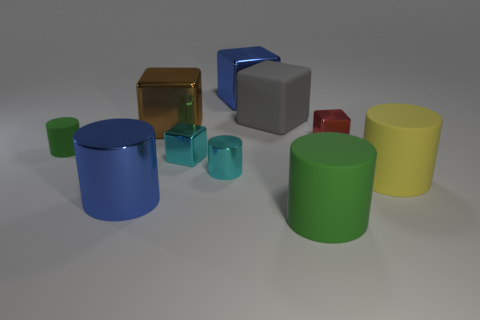The tiny red object that is the same material as the brown object is what shape? cube 